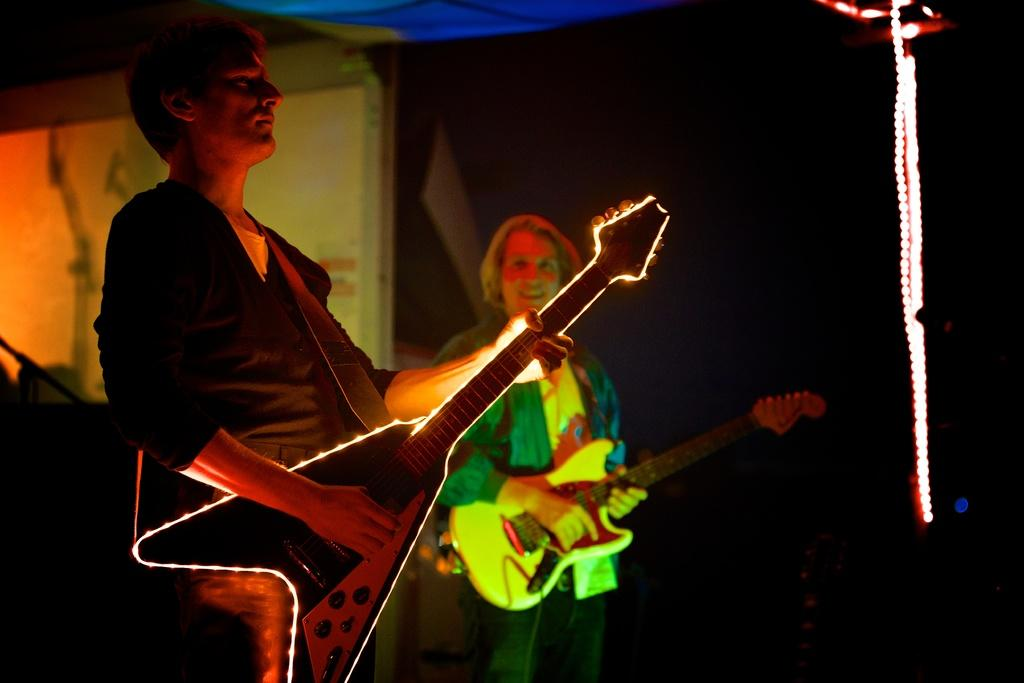How many people are in the image? There are two people in the image. What are the two people doing in the image? The two people are standing and holding a guitar. How many chairs are visible in the image? There are no chairs visible in the image. Is there an owl perched on the guitar in the image? No, there is no owl present in the image. 